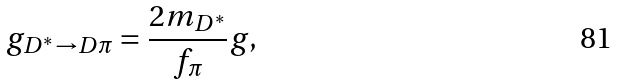Convert formula to latex. <formula><loc_0><loc_0><loc_500><loc_500>g _ { D ^ { \ast } \to D \pi } = \frac { 2 m _ { D ^ { \ast } } } { f _ { \pi } } g ,</formula> 